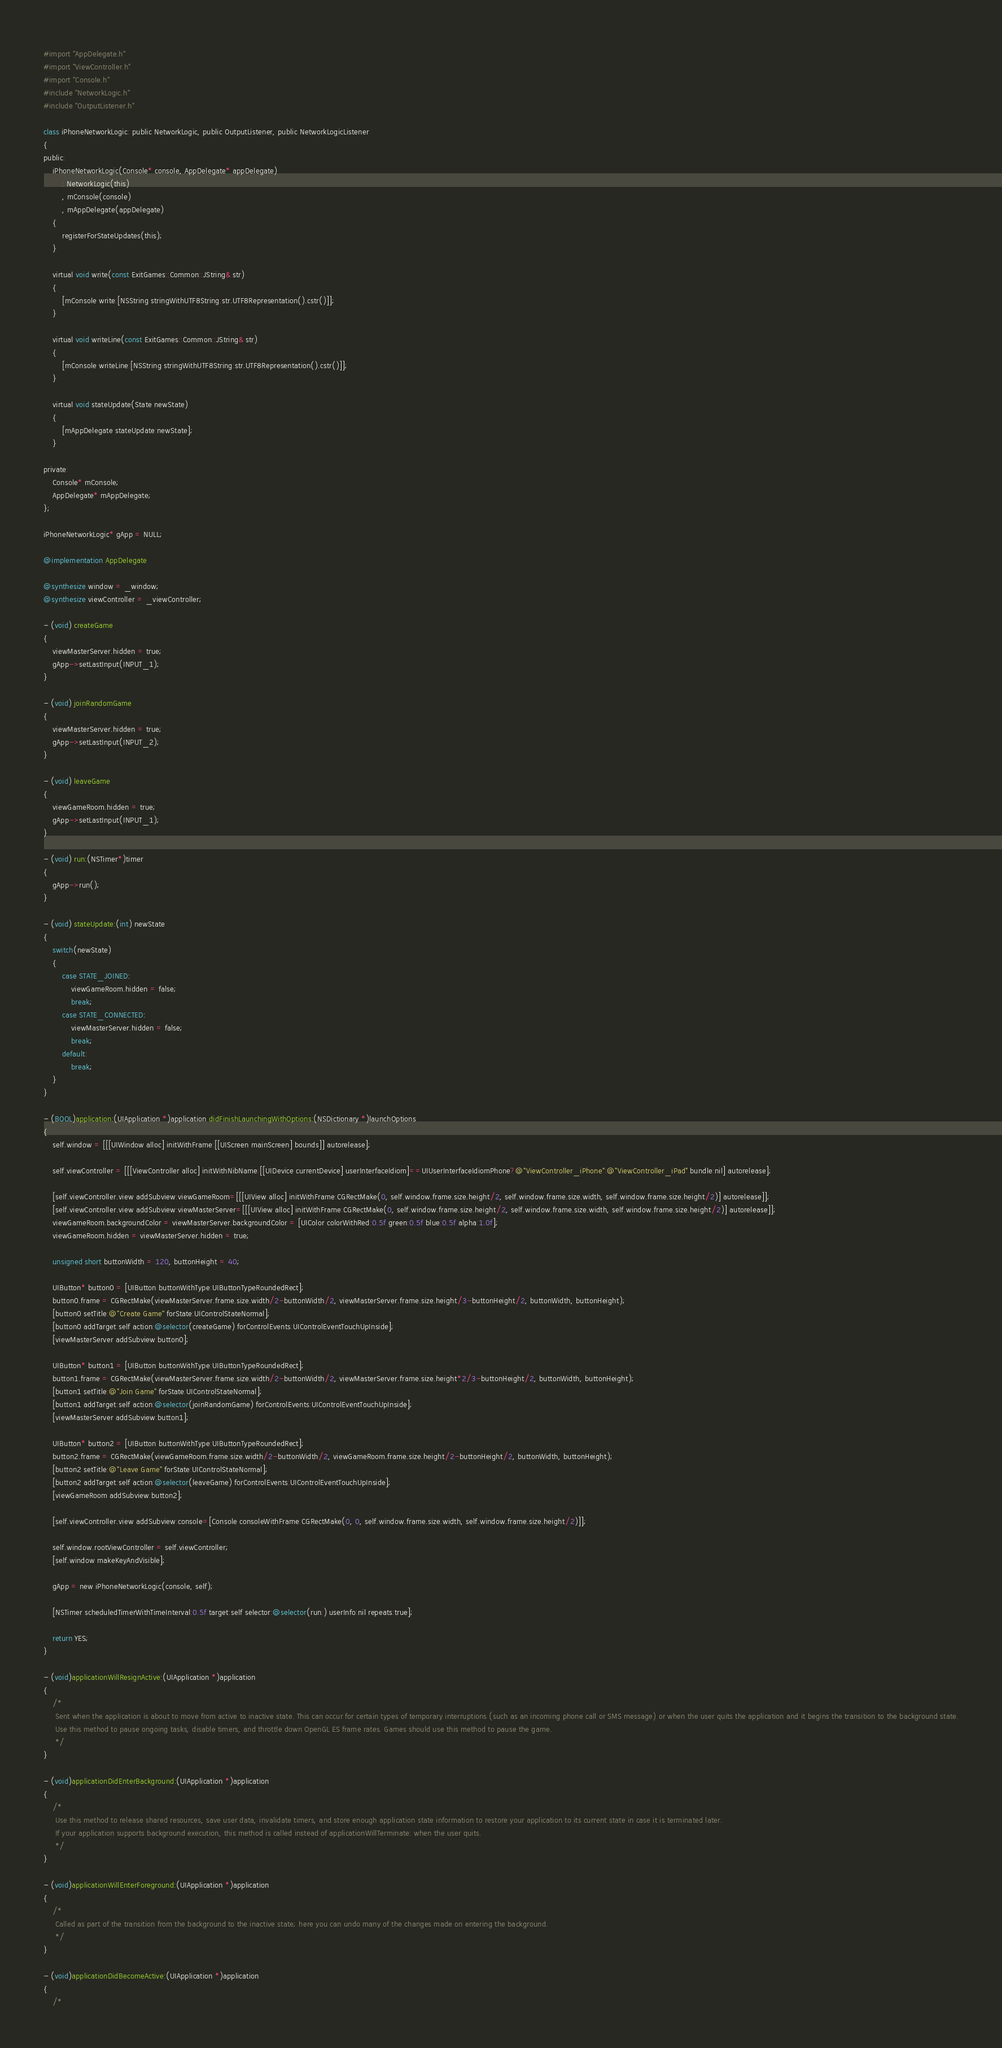<code> <loc_0><loc_0><loc_500><loc_500><_ObjectiveC_>#import "AppDelegate.h"
#import "ViewController.h"
#import "Console.h"
#include "NetworkLogic.h"
#include "OutputListener.h"

class iPhoneNetworkLogic: public NetworkLogic, public OutputListener, public NetworkLogicListener
{
public:
	iPhoneNetworkLogic(Console* console, AppDelegate* appDelegate)
		: NetworkLogic(this)
		, mConsole(console)
		, mAppDelegate(appDelegate)
	{
		registerForStateUpdates(this);
	}

	virtual void write(const ExitGames::Common::JString& str)
	{
		[mConsole write:[NSString stringWithUTF8String:str.UTF8Representation().cstr()]];
	}
	
	virtual void writeLine(const ExitGames::Common::JString& str)
	{
		[mConsole writeLine:[NSString stringWithUTF8String:str.UTF8Representation().cstr()]];
	}

	virtual void stateUpdate(State newState)
	{
		[mAppDelegate stateUpdate:newState];
	}

private:
	Console* mConsole;
	AppDelegate* mAppDelegate;
};

iPhoneNetworkLogic* gApp = NULL;

@implementation AppDelegate

@synthesize window = _window;
@synthesize viewController = _viewController;

- (void) createGame
{
	viewMasterServer.hidden = true;
	gApp->setLastInput(INPUT_1);
}

- (void) joinRandomGame
{
	viewMasterServer.hidden = true;
	gApp->setLastInput(INPUT_2);
}

- (void) leaveGame
{
	viewGameRoom.hidden = true;
	gApp->setLastInput(INPUT_1);
}

- (void) run:(NSTimer*)timer
{
	gApp->run();
}

- (void) stateUpdate:(int) newState
{
	switch(newState)
	{
		case STATE_JOINED:
			viewGameRoom.hidden = false;
			break;
		case STATE_CONNECTED:
			viewMasterServer.hidden = false;
			break;
		default:
			break;
	}
}

- (BOOL)application:(UIApplication *)application didFinishLaunchingWithOptions:(NSDictionary *)launchOptions
{
    self.window = [[[UIWindow alloc] initWithFrame:[[UIScreen mainScreen] bounds]] autorelease];

	self.viewController = [[[ViewController alloc] initWithNibName:[[UIDevice currentDevice] userInterfaceIdiom]==UIUserInterfaceIdiomPhone?@"ViewController_iPhone":@"ViewController_iPad" bundle:nil] autorelease];

	[self.viewController.view addSubview:viewGameRoom=[[[UIView alloc] initWithFrame:CGRectMake(0, self.window.frame.size.height/2, self.window.frame.size.width, self.window.frame.size.height/2)] autorelease]];
	[self.viewController.view addSubview:viewMasterServer=[[[UIView alloc] initWithFrame:CGRectMake(0, self.window.frame.size.height/2, self.window.frame.size.width, self.window.frame.size.height/2)] autorelease]];
	viewGameRoom.backgroundColor = viewMasterServer.backgroundColor = [UIColor colorWithRed:0.5f green:0.5f blue:0.5f alpha:1.0f];
	viewGameRoom.hidden = viewMasterServer.hidden = true;
	
	unsigned short buttonWidth = 120, buttonHeight = 40;
	
	UIButton* button0 = [UIButton buttonWithType:UIButtonTypeRoundedRect];
	button0.frame = CGRectMake(viewMasterServer.frame.size.width/2-buttonWidth/2, viewMasterServer.frame.size.height/3-buttonHeight/2, buttonWidth, buttonHeight);
	[button0 setTitle:@"Create Game" forState:UIControlStateNormal];
	[button0 addTarget:self action:@selector(createGame) forControlEvents:UIControlEventTouchUpInside];
	[viewMasterServer addSubview:button0];
	
	UIButton* button1 = [UIButton buttonWithType:UIButtonTypeRoundedRect];
	button1.frame = CGRectMake(viewMasterServer.frame.size.width/2-buttonWidth/2, viewMasterServer.frame.size.height*2/3-buttonHeight/2, buttonWidth, buttonHeight);
	[button1 setTitle:@"Join Game" forState:UIControlStateNormal];
	[button1 addTarget:self action:@selector(joinRandomGame) forControlEvents:UIControlEventTouchUpInside];
	[viewMasterServer addSubview:button1];
	
	UIButton* button2 = [UIButton buttonWithType:UIButtonTypeRoundedRect];
	button2.frame = CGRectMake(viewGameRoom.frame.size.width/2-buttonWidth/2, viewGameRoom.frame.size.height/2-buttonHeight/2, buttonWidth, buttonHeight);
	[button2 setTitle:@"Leave Game" forState:UIControlStateNormal];
	[button2 addTarget:self action:@selector(leaveGame) forControlEvents:UIControlEventTouchUpInside];
	[viewGameRoom addSubview:button2];
	
	[self.viewController.view addSubview:console=[Console consoleWithFrame:CGRectMake(0, 0, self.window.frame.size.width, self.window.frame.size.height/2)]];
	
	self.window.rootViewController = self.viewController;
    [self.window makeKeyAndVisible];

	gApp = new iPhoneNetworkLogic(console, self);

	[NSTimer scheduledTimerWithTimeInterval:0.5f target:self selector:@selector(run:) userInfo:nil repeats:true];

    return YES;
}

- (void)applicationWillResignActive:(UIApplication *)application
{
	/*
	 Sent when the application is about to move from active to inactive state. This can occur for certain types of temporary interruptions (such as an incoming phone call or SMS message) or when the user quits the application and it begins the transition to the background state.
	 Use this method to pause ongoing tasks, disable timers, and throttle down OpenGL ES frame rates. Games should use this method to pause the game.
	 */
}

- (void)applicationDidEnterBackground:(UIApplication *)application
{
	/*
	 Use this method to release shared resources, save user data, invalidate timers, and store enough application state information to restore your application to its current state in case it is terminated later. 
	 If your application supports background execution, this method is called instead of applicationWillTerminate: when the user quits.
	 */
}

- (void)applicationWillEnterForeground:(UIApplication *)application
{
	/*
	 Called as part of the transition from the background to the inactive state; here you can undo many of the changes made on entering the background.
	 */
}

- (void)applicationDidBecomeActive:(UIApplication *)application
{
	/*</code> 